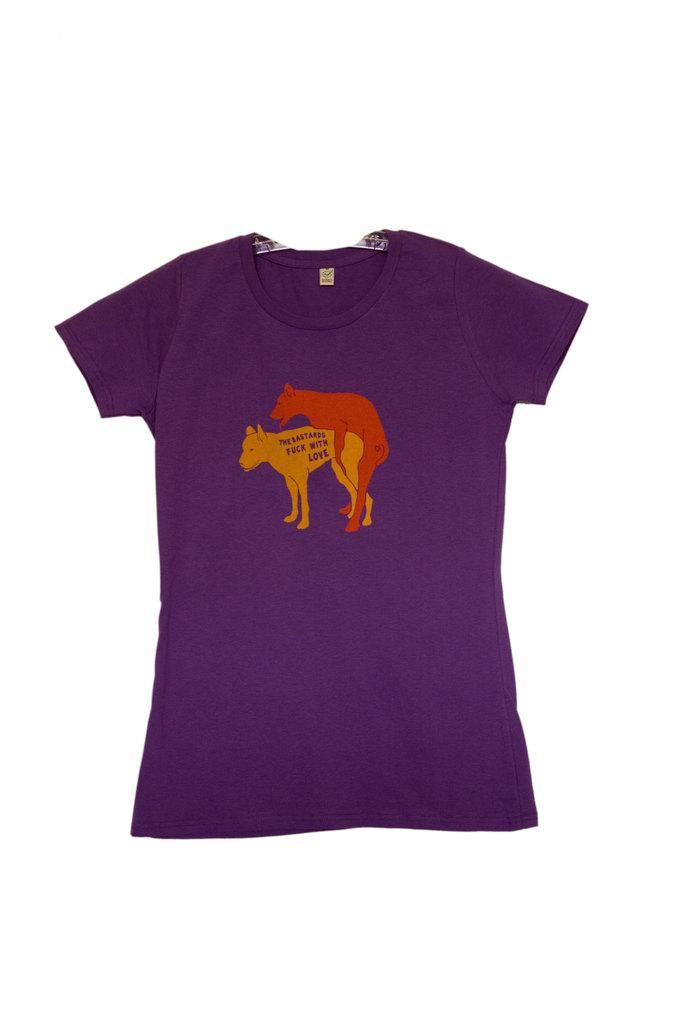In one or two sentences, can you explain what this image depicts? It is a blue color t-shirt, there are pictures of animals on it. 